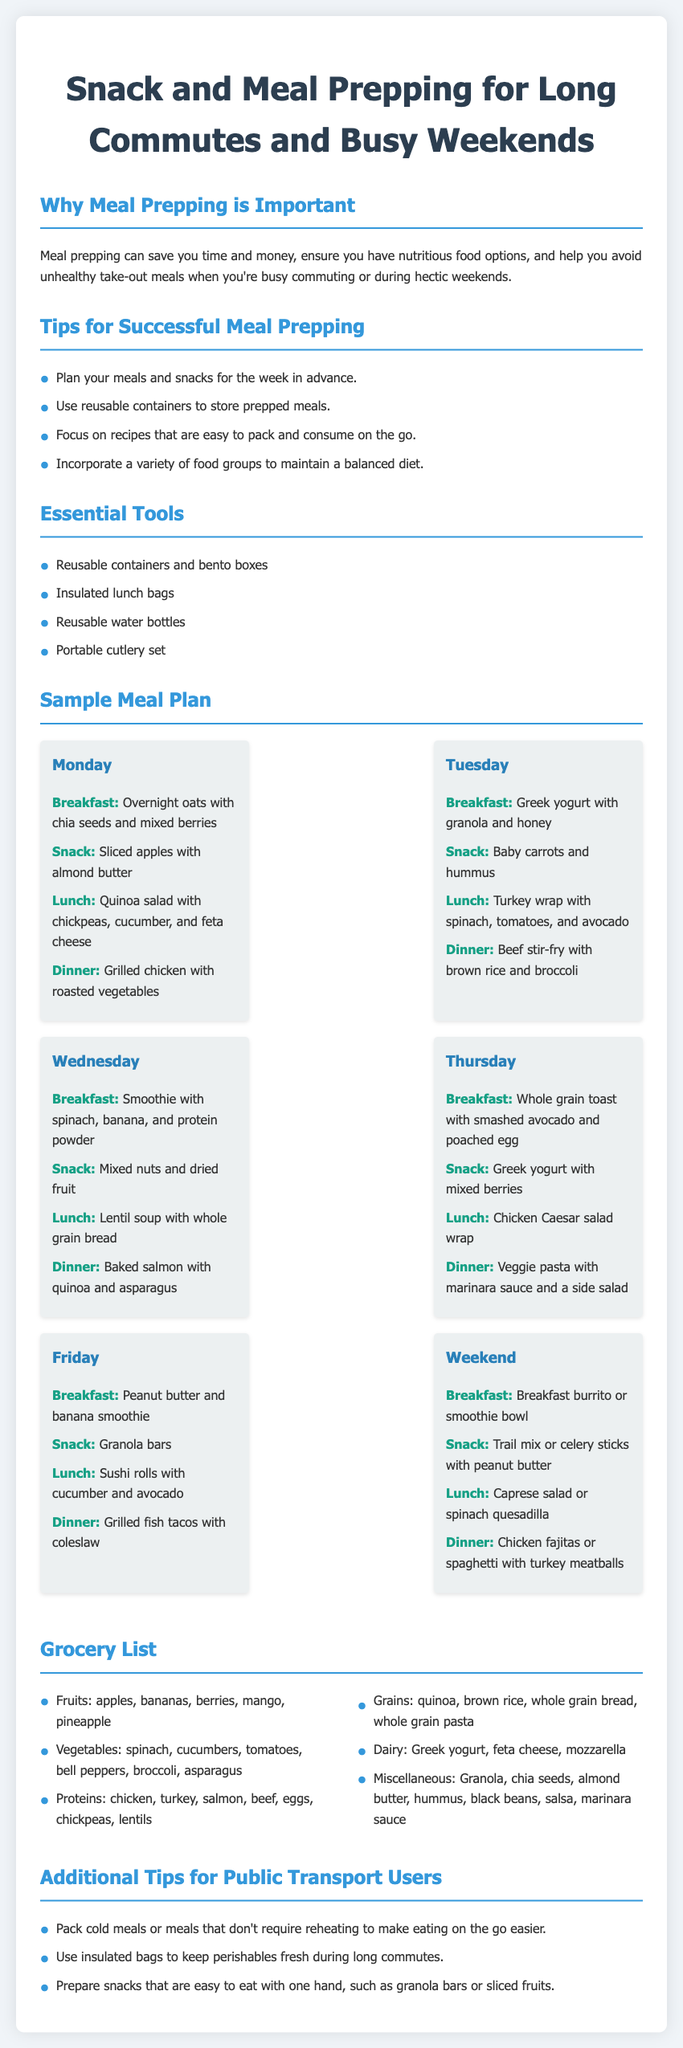What is the title of the document? The title of the document appears at the top and is "Snack and Meal Prepping for Long Commutes and Busy Weekends".
Answer: Snack and Meal Prepping for Long Commutes and Busy Weekends How many days are included in the sample meal plan? The sample meal plan includes meals for Monday, Tuesday, Wednesday, Thursday, Friday, and the Weekend, which totals 6 days.
Answer: 6 days What is the snack for Tuesday? The snack for Tuesday is listed in the meal plan as "Baby carrots and hummus".
Answer: Baby carrots and hummus Which meal includes quinoa and chickpeas? The meal that includes quinoa and chickpeas is "Lunch" on Monday, which is a "Quinoa salad with chickpeas, cucumber, and feta cheese".
Answer: Lunch on Monday What is a suggested tool for meal prepping? One of the essential tools listed for meal prepping is "Insulated lunch bags".
Answer: Insulated lunch bags What type of salad is mentioned for Friday's lunch? The type of salad mentioned for Friday's lunch is "Sushi rolls with cucumber and avocado".
Answer: Sushi rolls with cucumber and avocado What snack is recommended for the weekend? The recommended snack for the weekend is "Trail mix or celery sticks with peanut butter".
Answer: Trail mix or celery sticks with peanut butter What should you avoid during busy commutes? The document mentions avoiding "unhealthy take-out meals" during busy commutes.
Answer: unhealthy take-out meals What is suggested to keep perishables fresh? It is suggested to use "insulated bags" to keep perishables fresh during long commutes.
Answer: insulated bags 